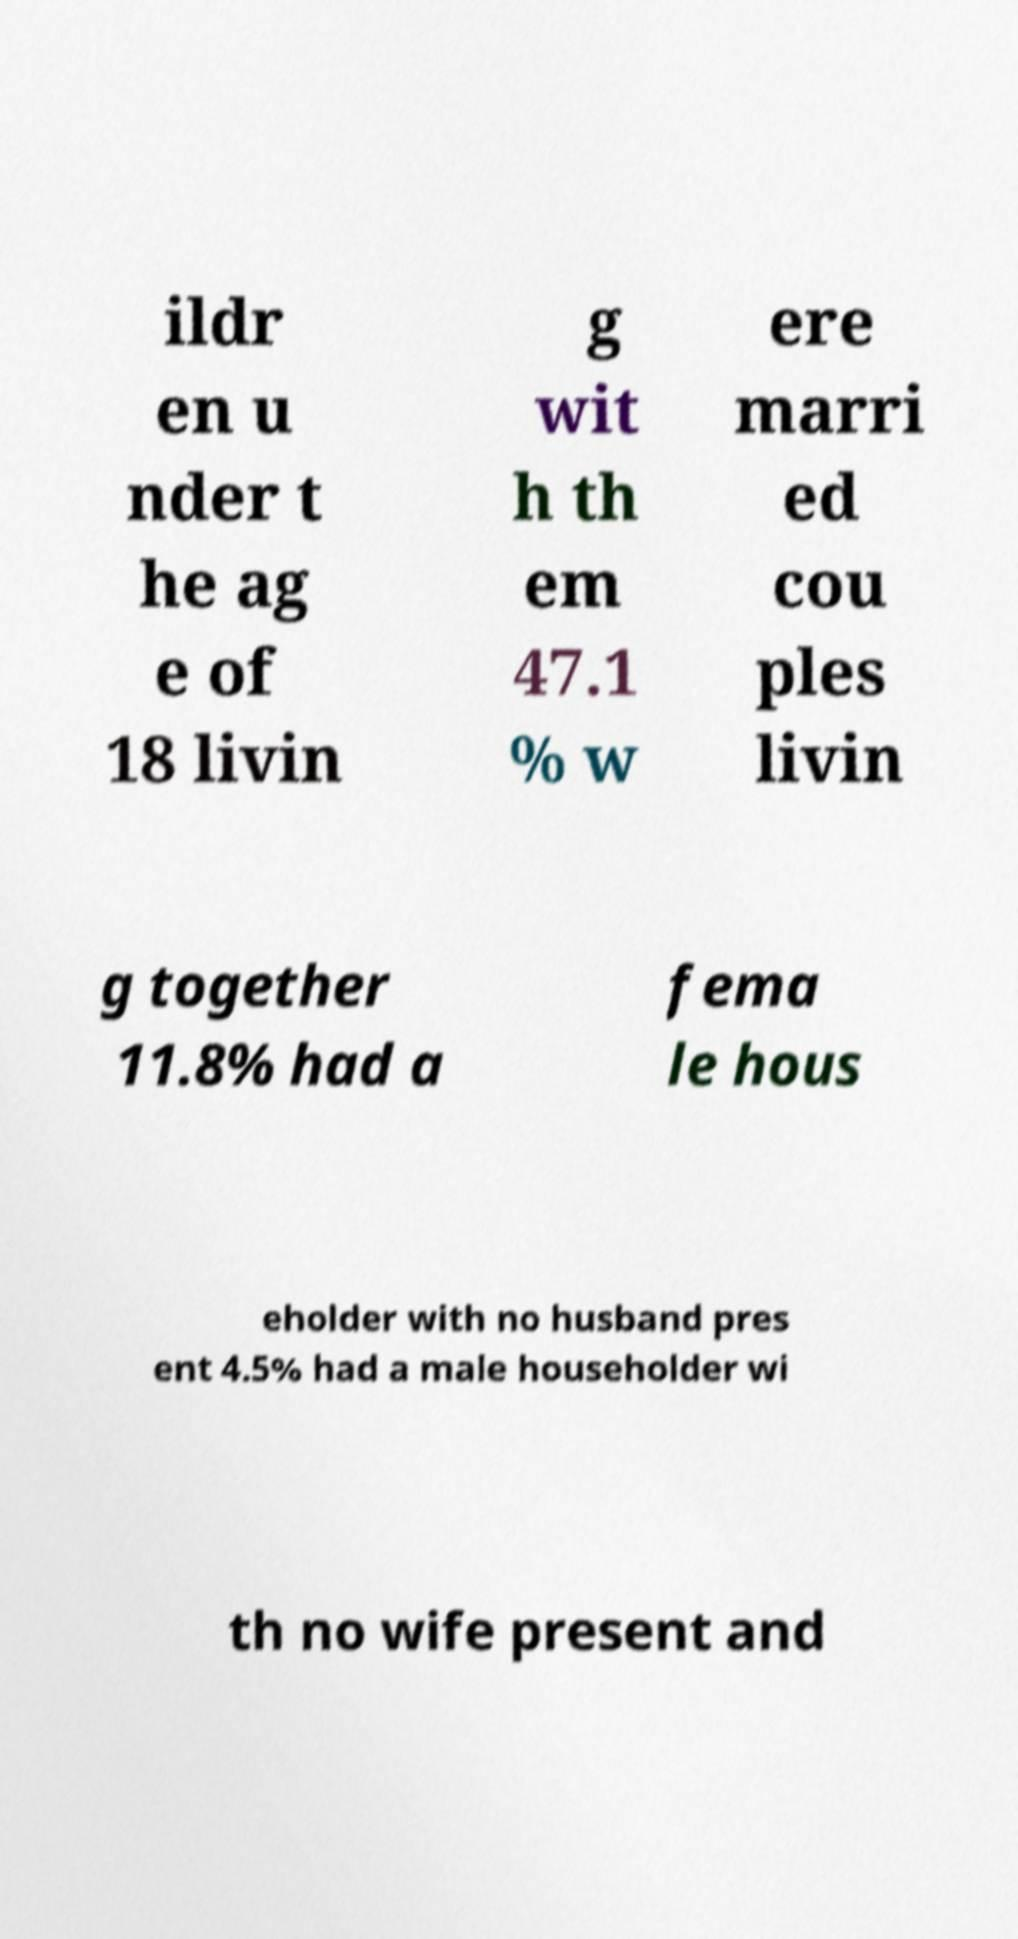There's text embedded in this image that I need extracted. Can you transcribe it verbatim? ildr en u nder t he ag e of 18 livin g wit h th em 47.1 % w ere marri ed cou ples livin g together 11.8% had a fema le hous eholder with no husband pres ent 4.5% had a male householder wi th no wife present and 